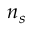Convert formula to latex. <formula><loc_0><loc_0><loc_500><loc_500>n _ { s }</formula> 